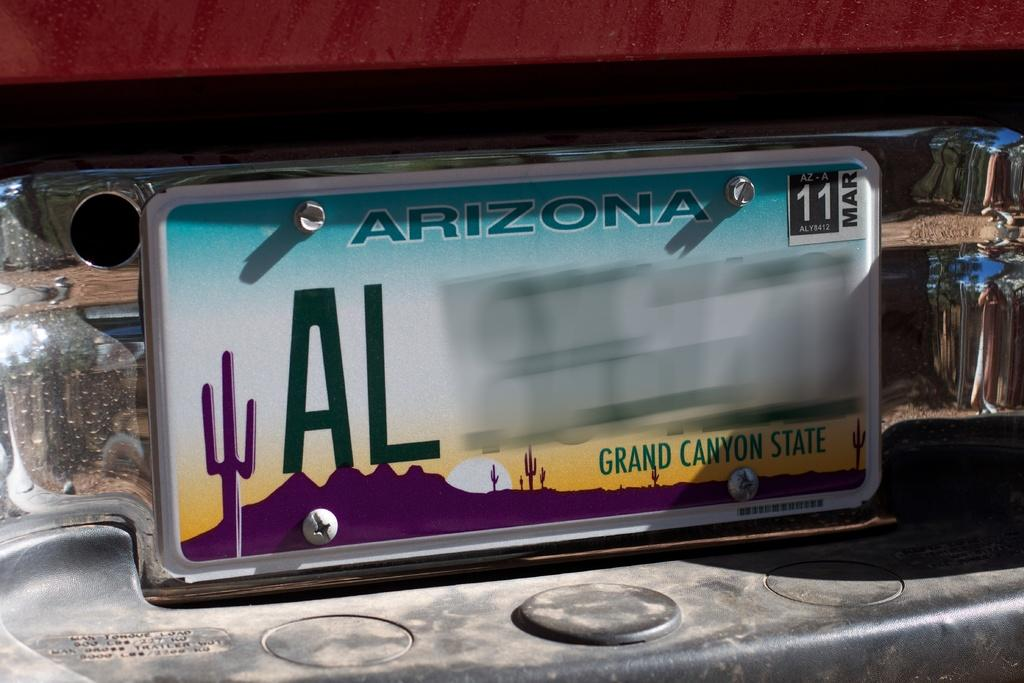<image>
Create a compact narrative representing the image presented. The Arizona plate is registered until Mar 11. 